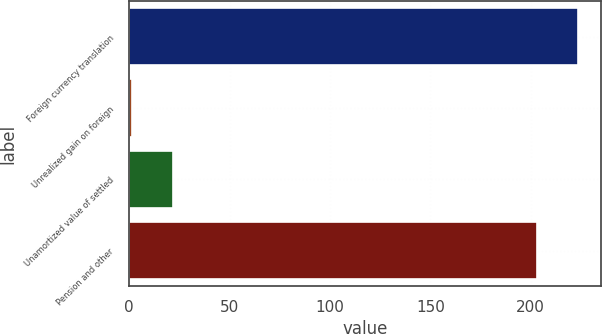Convert chart. <chart><loc_0><loc_0><loc_500><loc_500><bar_chart><fcel>Foreign currency translation<fcel>Unrealized gain on foreign<fcel>Unamortized value of settled<fcel>Pension and other<nl><fcel>223.61<fcel>1.5<fcel>22.01<fcel>203.1<nl></chart> 